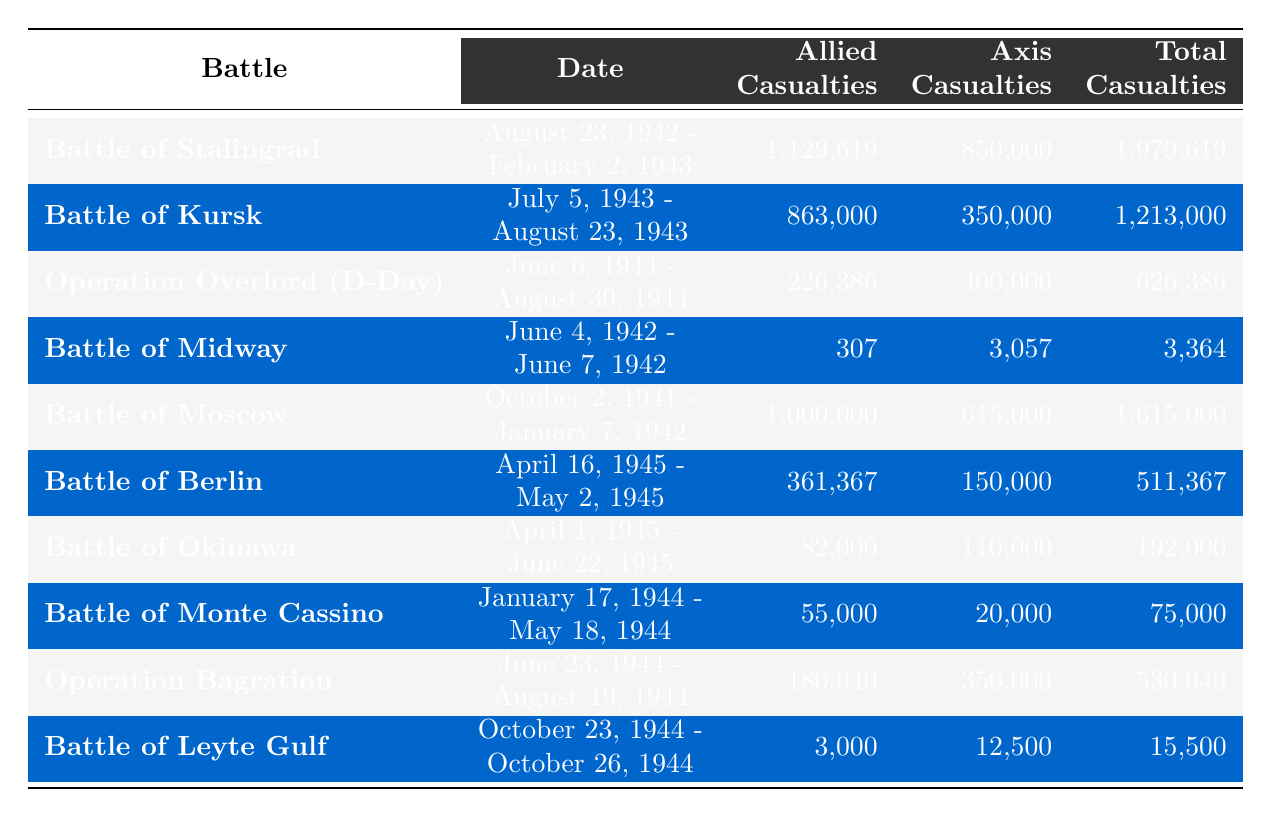What was the total number of casualties in the Battle of Stalingrad? Referring to the table, the total casualties listed for the Battle of Stalingrad are 1,979,619.
Answer: 1,979,619 Which battle had the highest number of Allied casualties? Looking through the table, the Battle of Stalingrad recorded the highest Allied casualties at 1,129,619.
Answer: Battle of Stalingrad What is the difference in total casualties between the Battle of Kursk and the Battle of Midway? The total casualties for the Battle of Kursk are 1,213,000 and for the Battle of Midway are 3,364. The difference is 1,213,000 - 3,364 = 1,209,636.
Answer: 1,209,636 Did the Battle of Berlin have more Allied casualties than the Battle of Okinawa? The Battle of Berlin had 361,367 Allied casualties, whereas the Battle of Okinawa had 82,000. Therefore, yes, it did have more.
Answer: Yes What is the total number of Allied casualties in battles that occurred in 1944? Referencing the table, the battles and their respective Allied casualties in 1944 are: Operation Overlord (226,386), Operation Bagration (180,040), and the Battle of Leyte Gulf (3,000). When summed: 226,386 + 180,040 + 3,000 = 409,426.
Answer: 409,426 Which battle had the least total casualties, and what was the number? The table shows that the Battle of Midway had the least total casualties at 3,364.
Answer: Battle of Midway, 3,364 Were the total casualties in the Battle of Moscow greater than the total casualties in the Battle of Berlin? From the table, the Battle of Moscow has total casualties of 1,615,000 and the Battle of Berlin has 511,367. Since 1,615,000 > 511,367, the answer is yes.
Answer: Yes What percentage of the total casualties in the Battle of Stalingrad were Allied casualties? The total casualties in the Battle of Stalingrad are 1,979,619, and Allied casualties are 1,129,619. To find the percentage: (1,129,619 / 1,979,619) * 100 = approximately 57.1%.
Answer: 57.1% How many battles had more than 400,000 Axis casualties? By reviewing the table, the battles with more than 400,000 Axis casualties are: the Battle of Stalingrad, the Battle of Kursk, Operation Overlord, the Battle of Moscow, and Operation Bagration. That totals 5 battles.
Answer: 5 What was the average number of total casualties across all listed battles? To find the average, sum all the total casualties: 1,979,619 (Stalingrad) + 1,213,000 (Kursk) + 626,386 (D-Day) + 3,364 (Midway) + 1,615,000 (Moscow) + 511,367 (Berlin) + 192,000 (Okinawa) + 75,000 (Monte Cassino) + 530,040 (Bagration) + 15,500 (Leyte Gulf) = 6,658,776. There are 10 battles total, so the average is 6,658,776 / 10 = 665,877.6.
Answer: 665,877.6 